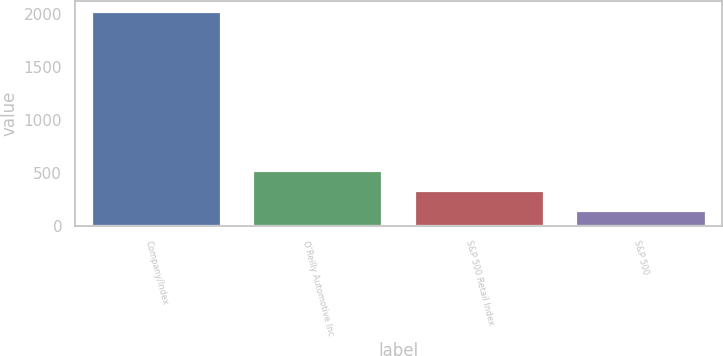<chart> <loc_0><loc_0><loc_500><loc_500><bar_chart><fcel>Company/Index<fcel>O'Reilly Automotive Inc<fcel>S&P 500 Retail Index<fcel>S&P 500<nl><fcel>2015<fcel>517.4<fcel>330.2<fcel>143<nl></chart> 